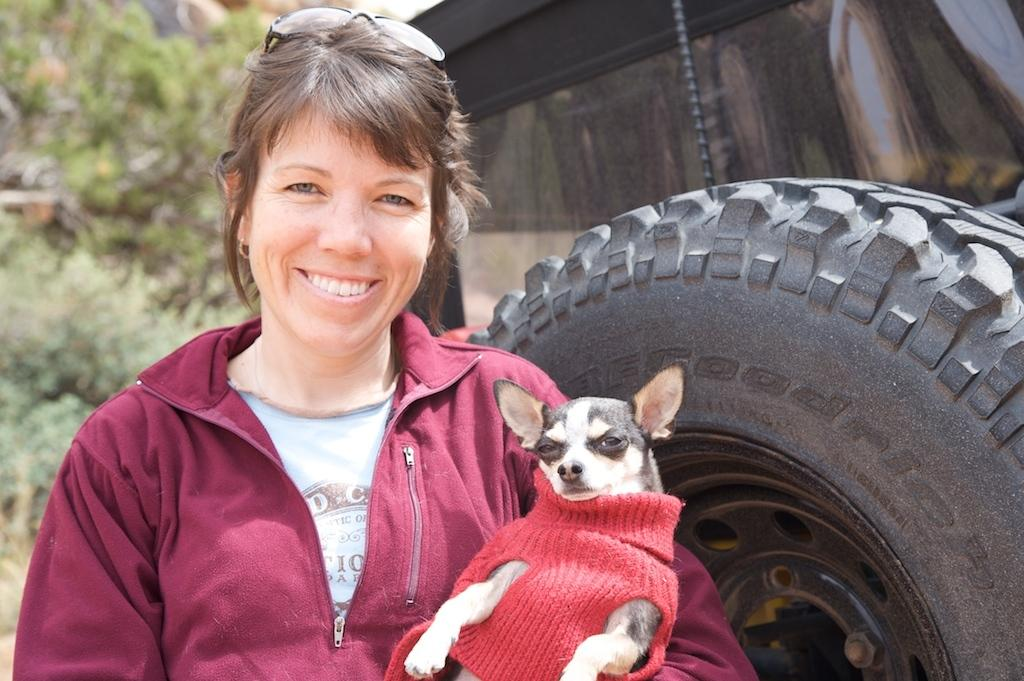Who is in the image? There is a woman in the image. What is the woman holding? The woman is holding a dog. What can be seen on the woman's face? The woman is wearing glasses. What is visible in the background of the image? There is a vehicle and trees in the background of the image. What color is the woman's hoodie? The woman is wearing a maroon-colored hoodie. What is the dog wearing? The dog is wearing a red-colored shirt. How many basketballs can be seen in the image? There are no basketballs present in the image. What trick is the woman performing with the dog in the image? There is no trick being performed in the image; the woman is simply holding the dog. 